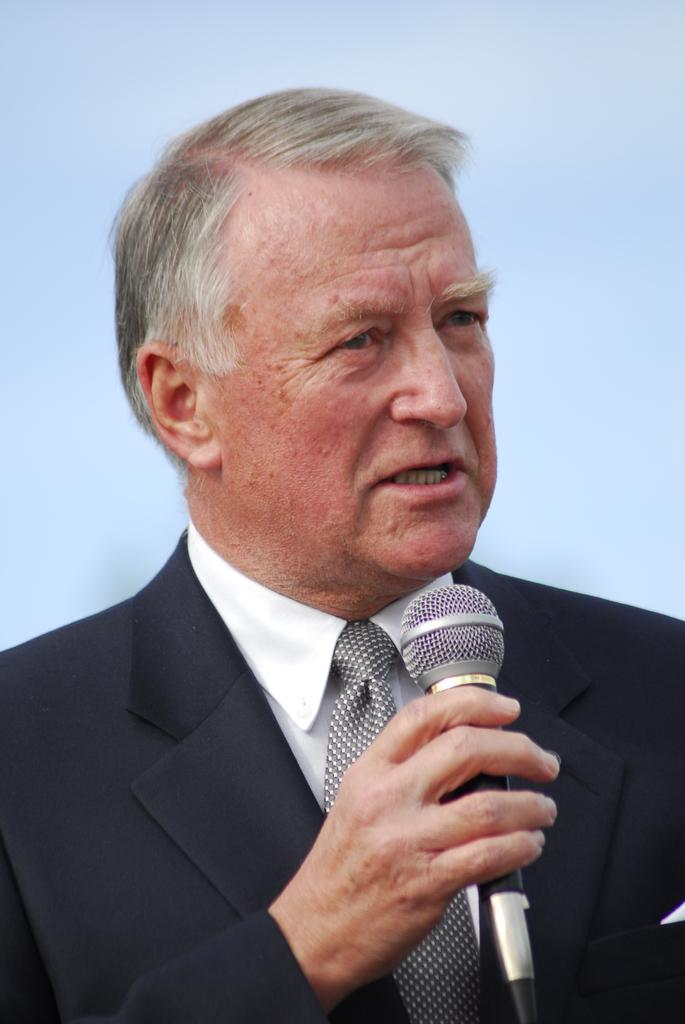Who is the main subject in the image? There is an old man in the image. What is the old man doing in the image? The old man is speaking in the image. What object is the old man holding in his hand? The old man is holding a microphone in his hand. What color is the hydrant next to the old man in the image? There is no hydrant present in the image. How does the honey taste in the image? There is no honey present in the image. 